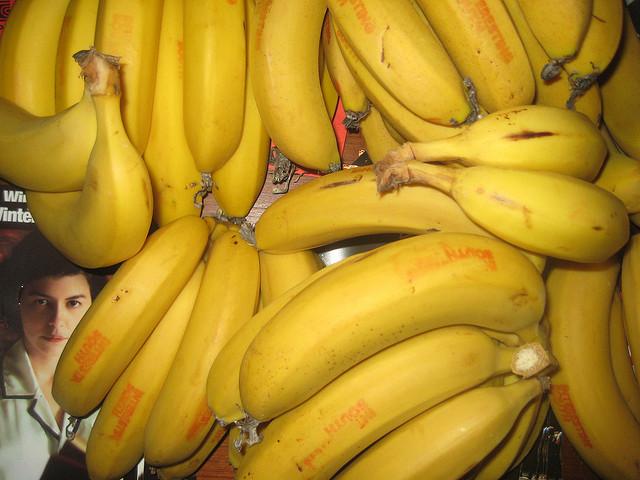Are these plantains?
Give a very brief answer. No. What color are the banana's?
Keep it brief. Yellow. Are any people visible?
Be succinct. Yes. Are they ripe?
Be succinct. Yes. What color are the eyes?
Short answer required. Brown. What color is the fruit?
Give a very brief answer. Yellow. Are these ripe?
Short answer required. Yes. Which fruits are these?
Concise answer only. Bananas. Are the bananas ripe?
Write a very short answer. Yes. Are the bananas the only fruit shown?
Short answer required. Yes. What color is this fruit?
Answer briefly. Yellow. How many bananas are there?
Answer briefly. 30. How many faces are visible in this photo?
Quick response, please. 1. Are the bananas ready to eat?
Quick response, please. Yes. Are there stickers on any of the bananas?
Give a very brief answer. No. 